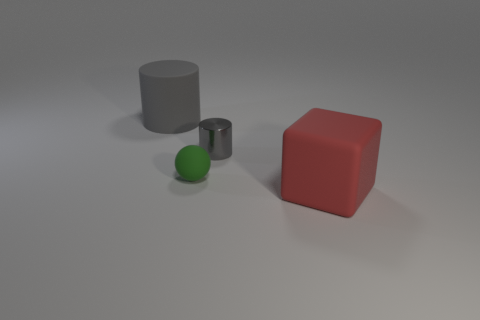There is a cylinder that is to the right of the large gray cylinder; is it the same color as the big thing behind the large red thing?
Your answer should be compact. Yes. Are there fewer tiny metal objects than small red cylinders?
Keep it short and to the point. No. What shape is the gray thing to the right of the rubber thing that is to the left of the tiny ball?
Give a very brief answer. Cylinder. Are there any other things that have the same size as the metal thing?
Keep it short and to the point. Yes. There is a big object behind the large object that is in front of the large object behind the gray shiny cylinder; what is its shape?
Make the answer very short. Cylinder. What number of things are objects that are behind the tiny gray object or gray cylinders on the left side of the gray metallic cylinder?
Make the answer very short. 1. There is a gray matte object; does it have the same size as the cylinder that is in front of the gray matte cylinder?
Ensure brevity in your answer.  No. Are the big object that is behind the red object and the small object that is in front of the small gray shiny cylinder made of the same material?
Give a very brief answer. Yes. Is the number of big gray matte things that are in front of the small green rubber ball the same as the number of green matte spheres on the right side of the shiny thing?
Provide a short and direct response. Yes. What number of things have the same color as the rubber cylinder?
Keep it short and to the point. 1. 